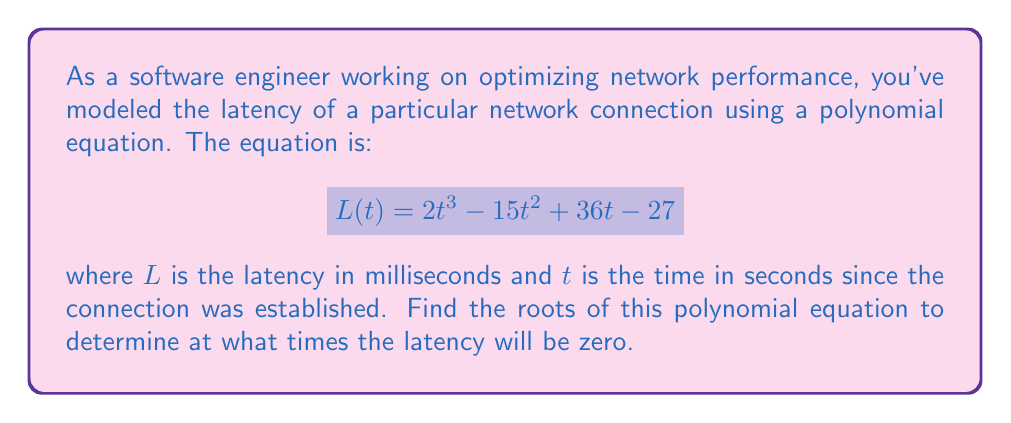What is the answer to this math problem? To find the roots of this polynomial equation, we need to solve:

$$ 2t^3 - 15t^2 + 36t - 27 = 0 $$

Let's approach this step-by-step:

1) First, we can factor out the greatest common factor:

   $$ 1(2t^3 - 15t^2 + 36t - 27) = 0 $$

2) This is a cubic equation. One way to solve it is to guess one root and then use polynomial long division to reduce it to a quadratic equation.

3) By inspection or trial and error, we can see that $t = 3$ is a root (as $2(3)^3 - 15(3)^2 + 36(3) - 27 = 54 - 135 + 108 - 27 = 0$).

4) Now we can divide the polynomial by $(t - 3)$:

   $$ \frac{2t^3 - 15t^2 + 36t - 27}{t - 3} = 2t^2 - 9t + 9 $$

5) So our equation becomes:

   $$ (t - 3)(2t^2 - 9t + 9) = 0 $$

6) We can solve $2t^2 - 9t + 9 = 0$ using the quadratic formula:

   $$ t = \frac{-b \pm \sqrt{b^2 - 4ac}}{2a} $$

   where $a = 2$, $b = -9$, and $c = 9$

7) Substituting these values:

   $$ t = \frac{9 \pm \sqrt{81 - 72}}{4} = \frac{9 \pm 3}{4} $$

8) This gives us two more roots:

   $$ t = \frac{9 + 3}{4} = 3 \quad \text{and} \quad t = \frac{9 - 3}{4} = \frac{3}{2} $$

Therefore, the roots of the equation are $t = 3$ (twice) and $t = \frac{3}{2}$.
Answer: The roots of the polynomial equation are $t = 3$ (a double root) and $t = \frac{3}{2}$. This means the network latency will be zero at 1.5 seconds and 3 seconds after the connection is established. 